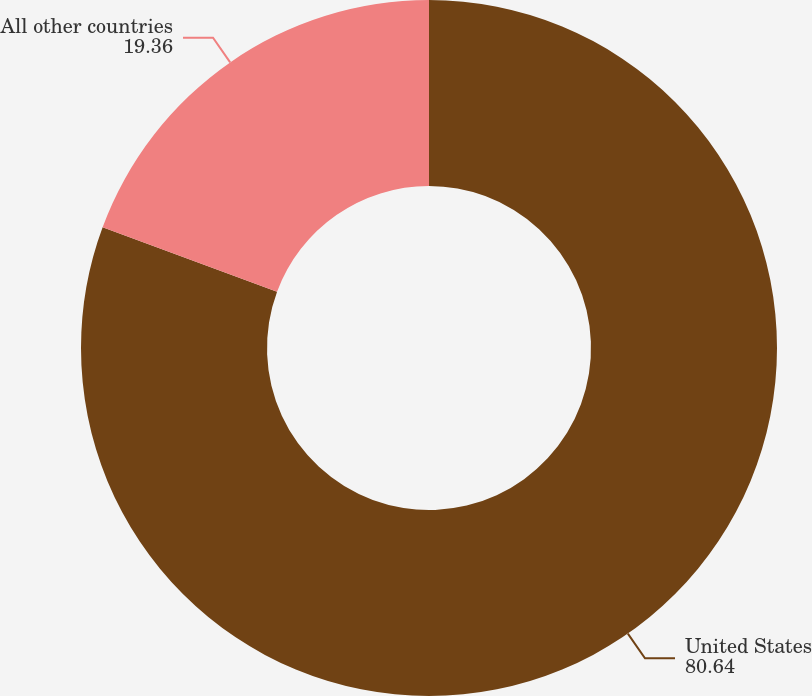Convert chart. <chart><loc_0><loc_0><loc_500><loc_500><pie_chart><fcel>United States<fcel>All other countries<nl><fcel>80.64%<fcel>19.36%<nl></chart> 